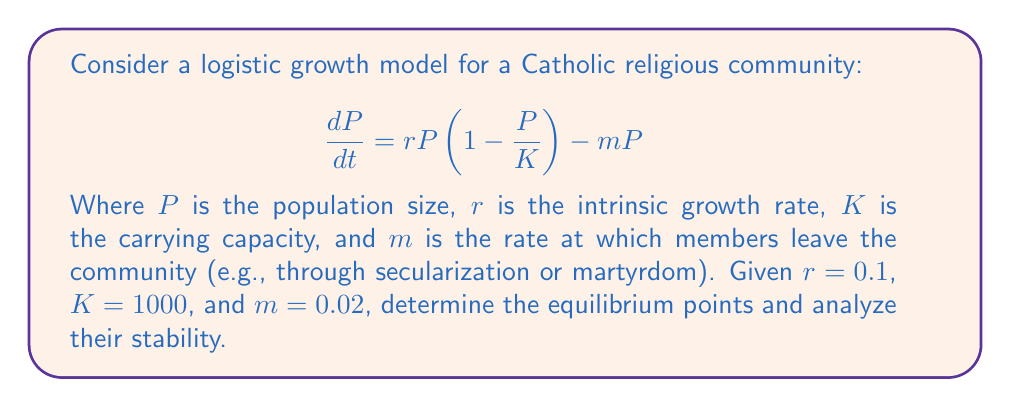Show me your answer to this math problem. 1. Find the equilibrium points by setting $\frac{dP}{dt} = 0$:

   $$0 = rP(1 - \frac{P}{K}) - mP$$
   $$0 = 0.1P(1 - \frac{P}{1000}) - 0.02P$$

2. Factor out $P$:

   $$0 = P(0.1 - 0.0001P - 0.02)$$
   $$0 = P(0.08 - 0.0001P)$$

3. Solve for $P$:
   
   $P = 0$ or $0.08 - 0.0001P = 0$
   $P = 0$ or $P = 800$

4. To analyze stability, find the derivative of $\frac{dP}{dt}$ with respect to $P$:

   $$\frac{d}{dP}(\frac{dP}{dt}) = r - \frac{2rP}{K} - m$$
   $$\frac{d}{dP}(\frac{dP}{dt}) = 0.1 - \frac{0.0002P}{1} - 0.02$$
   $$\frac{d}{dP}(\frac{dP}{dt}) = 0.08 - 0.0002P$$

5. Evaluate at each equilibrium point:

   At $P = 0$: $0.08 - 0.0002(0) = 0.08 > 0$ (unstable)
   At $P = 800$: $0.08 - 0.0002(800) = -0.08 < 0$ (stable)

6. Interpret the results:
   - $P = 0$ is an unstable equilibrium point, representing extinction.
   - $P = 800$ is a stable equilibrium point, representing a sustainable community size.
Answer: Equilibrium points: $P = 0$ (unstable) and $P = 800$ (stable) 